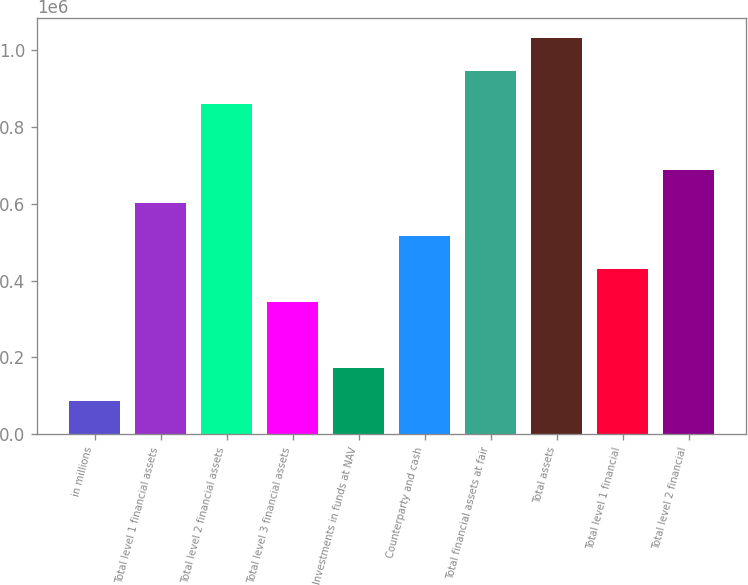Convert chart. <chart><loc_0><loc_0><loc_500><loc_500><bar_chart><fcel>in millions<fcel>Total level 1 financial assets<fcel>Total level 2 financial assets<fcel>Total level 3 financial assets<fcel>Investments in funds at NAV<fcel>Counterparty and cash<fcel>Total financial assets at fair<fcel>Total assets<fcel>Total level 1 financial<fcel>Total level 2 financial<nl><fcel>86023.6<fcel>602118<fcel>860165<fcel>344071<fcel>172039<fcel>516102<fcel>946181<fcel>1.0322e+06<fcel>430086<fcel>688134<nl></chart> 